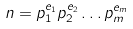Convert formula to latex. <formula><loc_0><loc_0><loc_500><loc_500>n = p _ { 1 } ^ { e _ { 1 } } p _ { 2 } ^ { e _ { 2 } } \dots p _ { m } ^ { e _ { m } }</formula> 